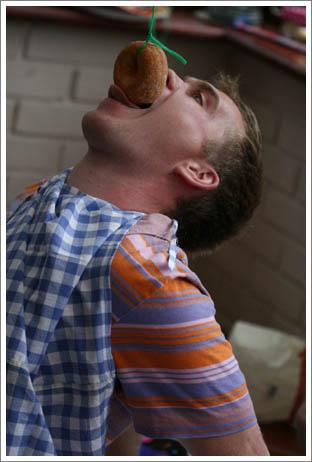What is the man wearing?
Quick response, please. Shirt. What is the man eating?
Quick response, please. Donut. What color string is holding the donut?
Concise answer only. Green. 